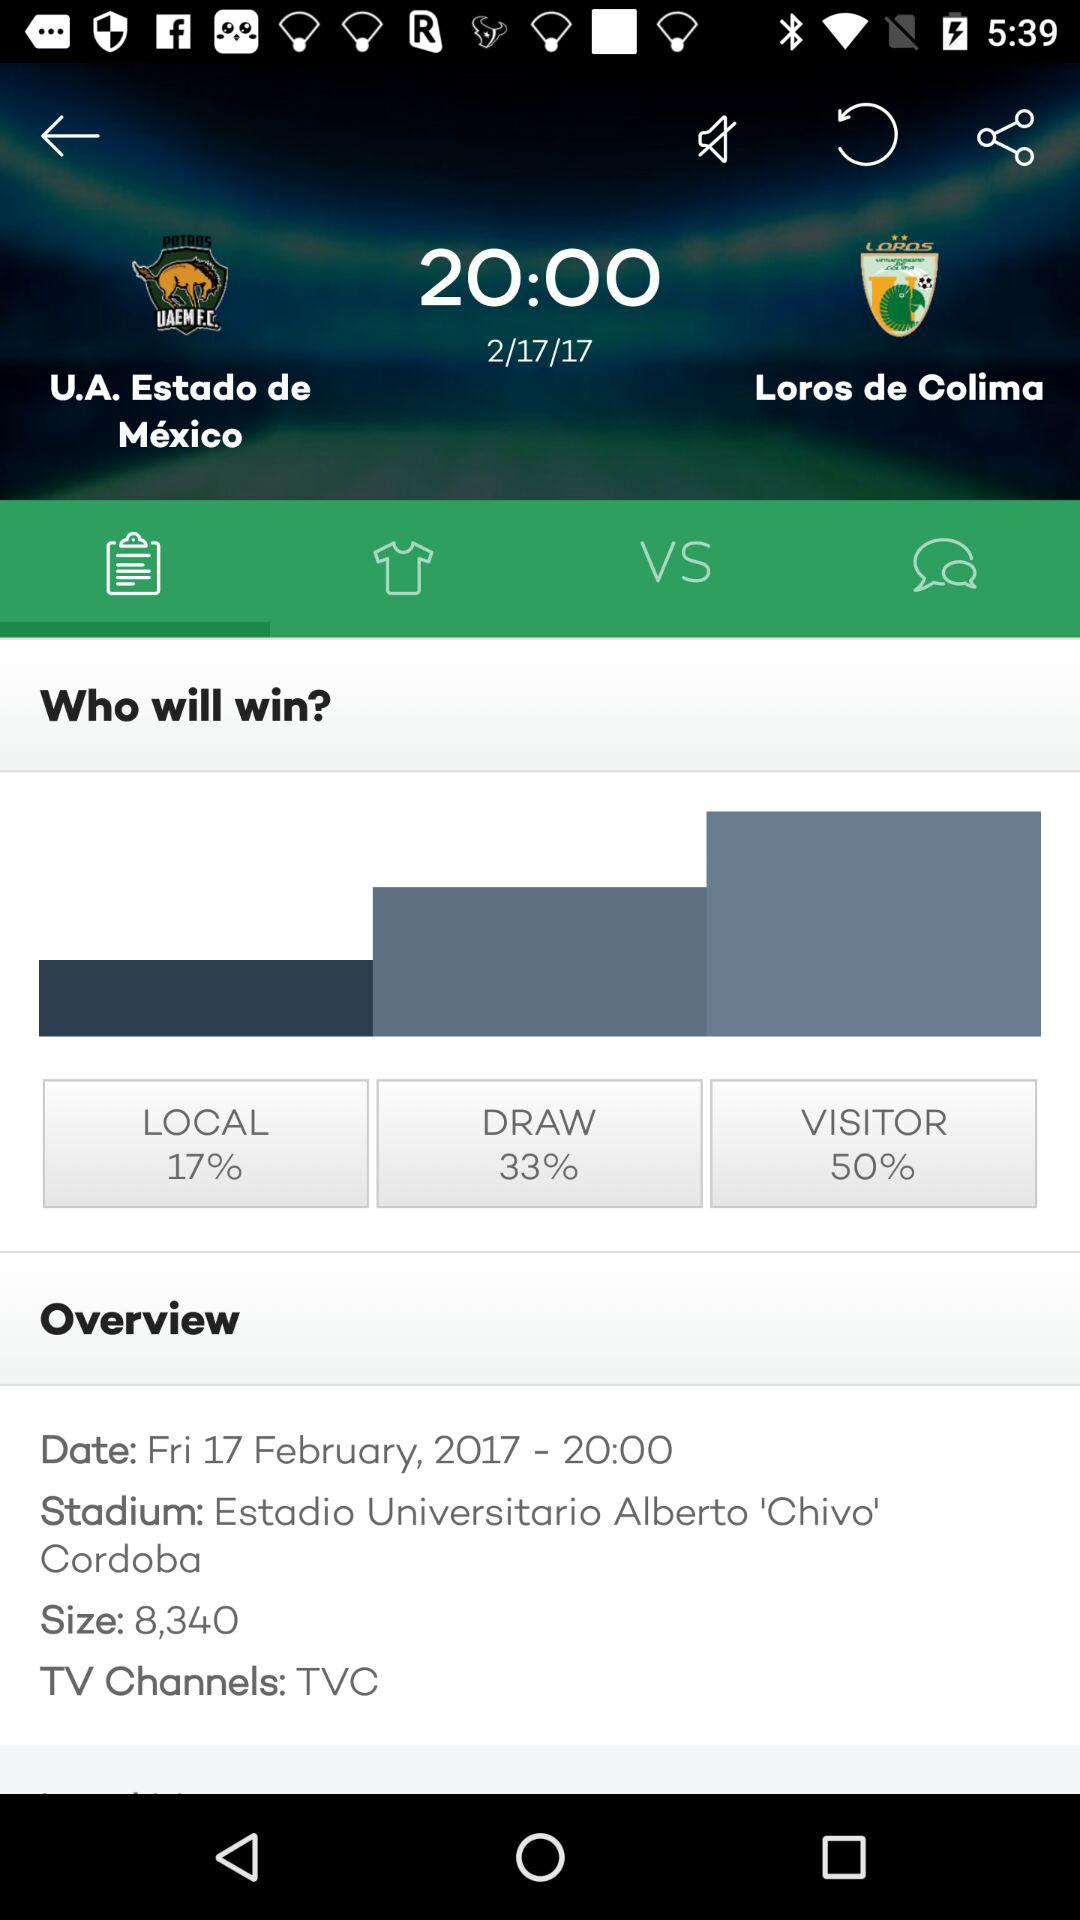What is the size? The size is 8,340. 